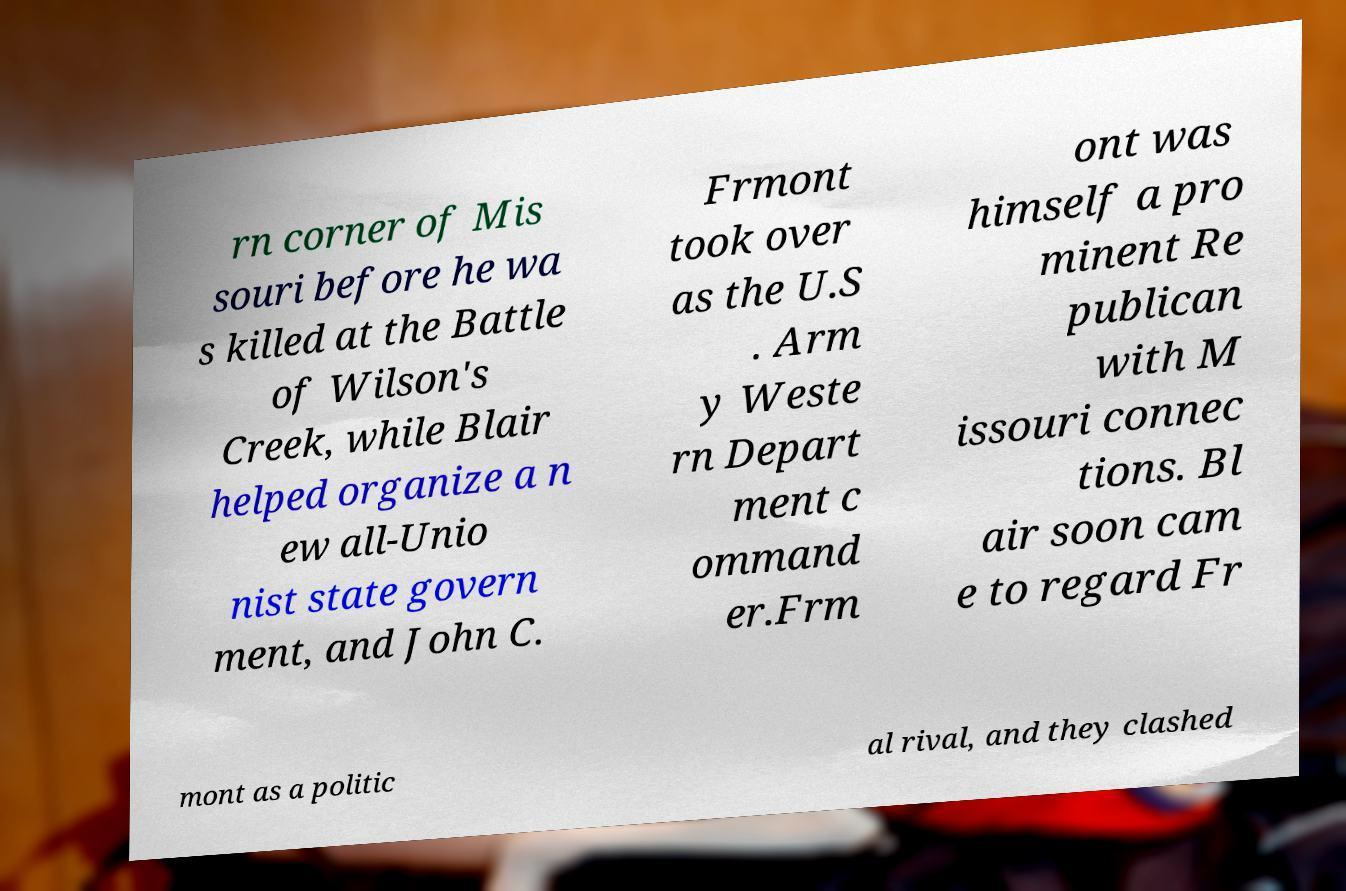Can you accurately transcribe the text from the provided image for me? rn corner of Mis souri before he wa s killed at the Battle of Wilson's Creek, while Blair helped organize a n ew all-Unio nist state govern ment, and John C. Frmont took over as the U.S . Arm y Weste rn Depart ment c ommand er.Frm ont was himself a pro minent Re publican with M issouri connec tions. Bl air soon cam e to regard Fr mont as a politic al rival, and they clashed 